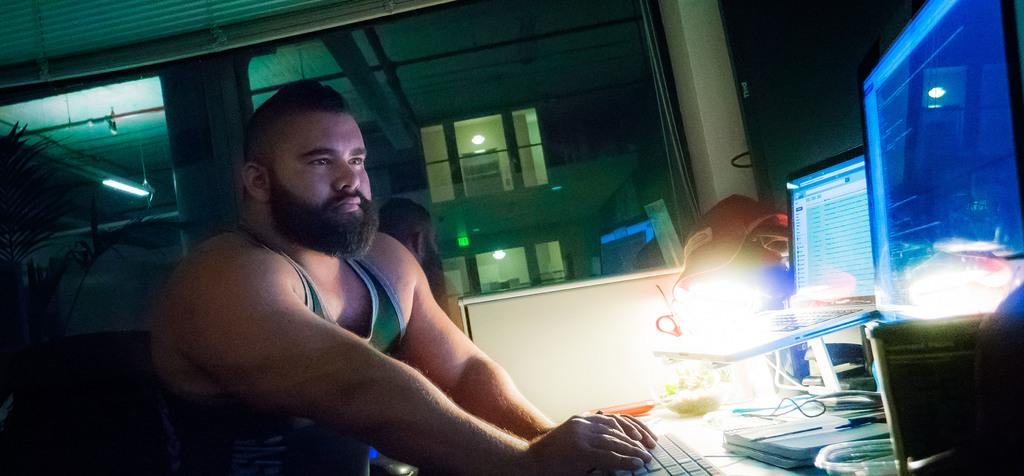Who is present in the image? There is a man in the image. What is the man doing with his hand? The man's hand is on a keyboard. How many screens can be seen in the image? There are two screens in the image. What can be seen in the background of the image? There is a plant and a tube light in the background of the image. What type of clam is being used as a paperweight on the keyboard in the image? There is no clam present in the image; the man's hand is on the keyboard. What kind of trouble is the man experiencing while working on the computer in the image? The image does not provide any information about the man's experience or any trouble he might be facing while working on the computer. 